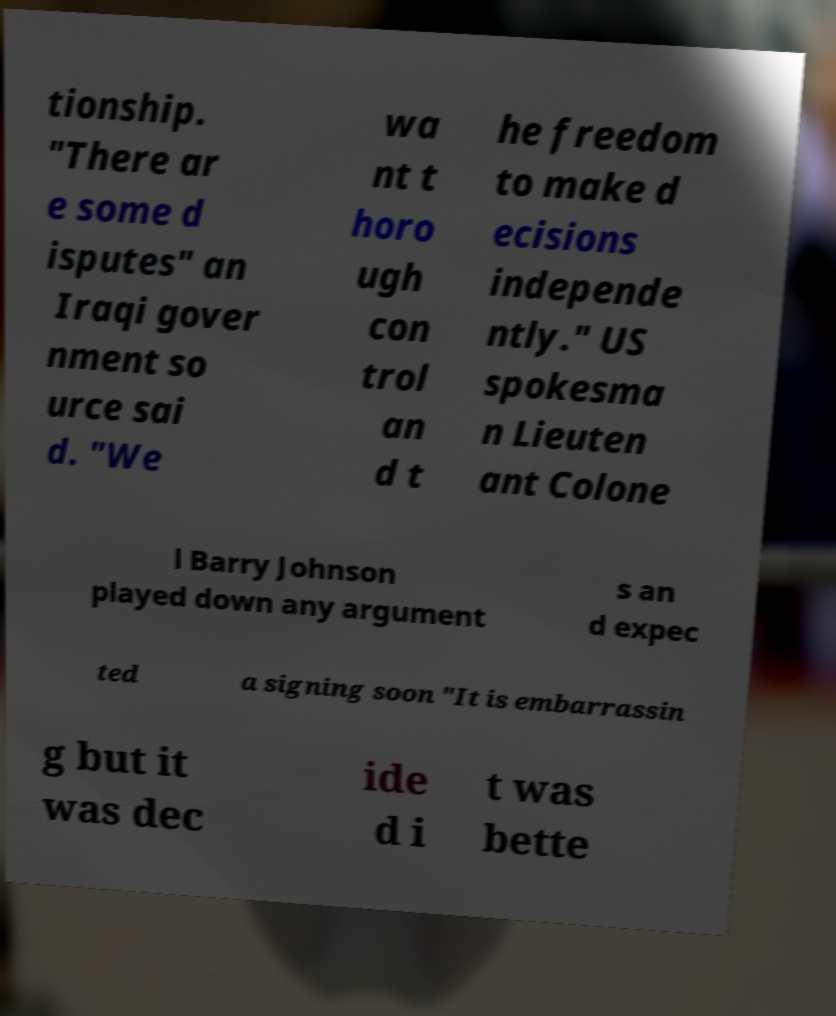Please identify and transcribe the text found in this image. tionship. "There ar e some d isputes" an Iraqi gover nment so urce sai d. "We wa nt t horo ugh con trol an d t he freedom to make d ecisions independe ntly." US spokesma n Lieuten ant Colone l Barry Johnson played down any argument s an d expec ted a signing soon "It is embarrassin g but it was dec ide d i t was bette 